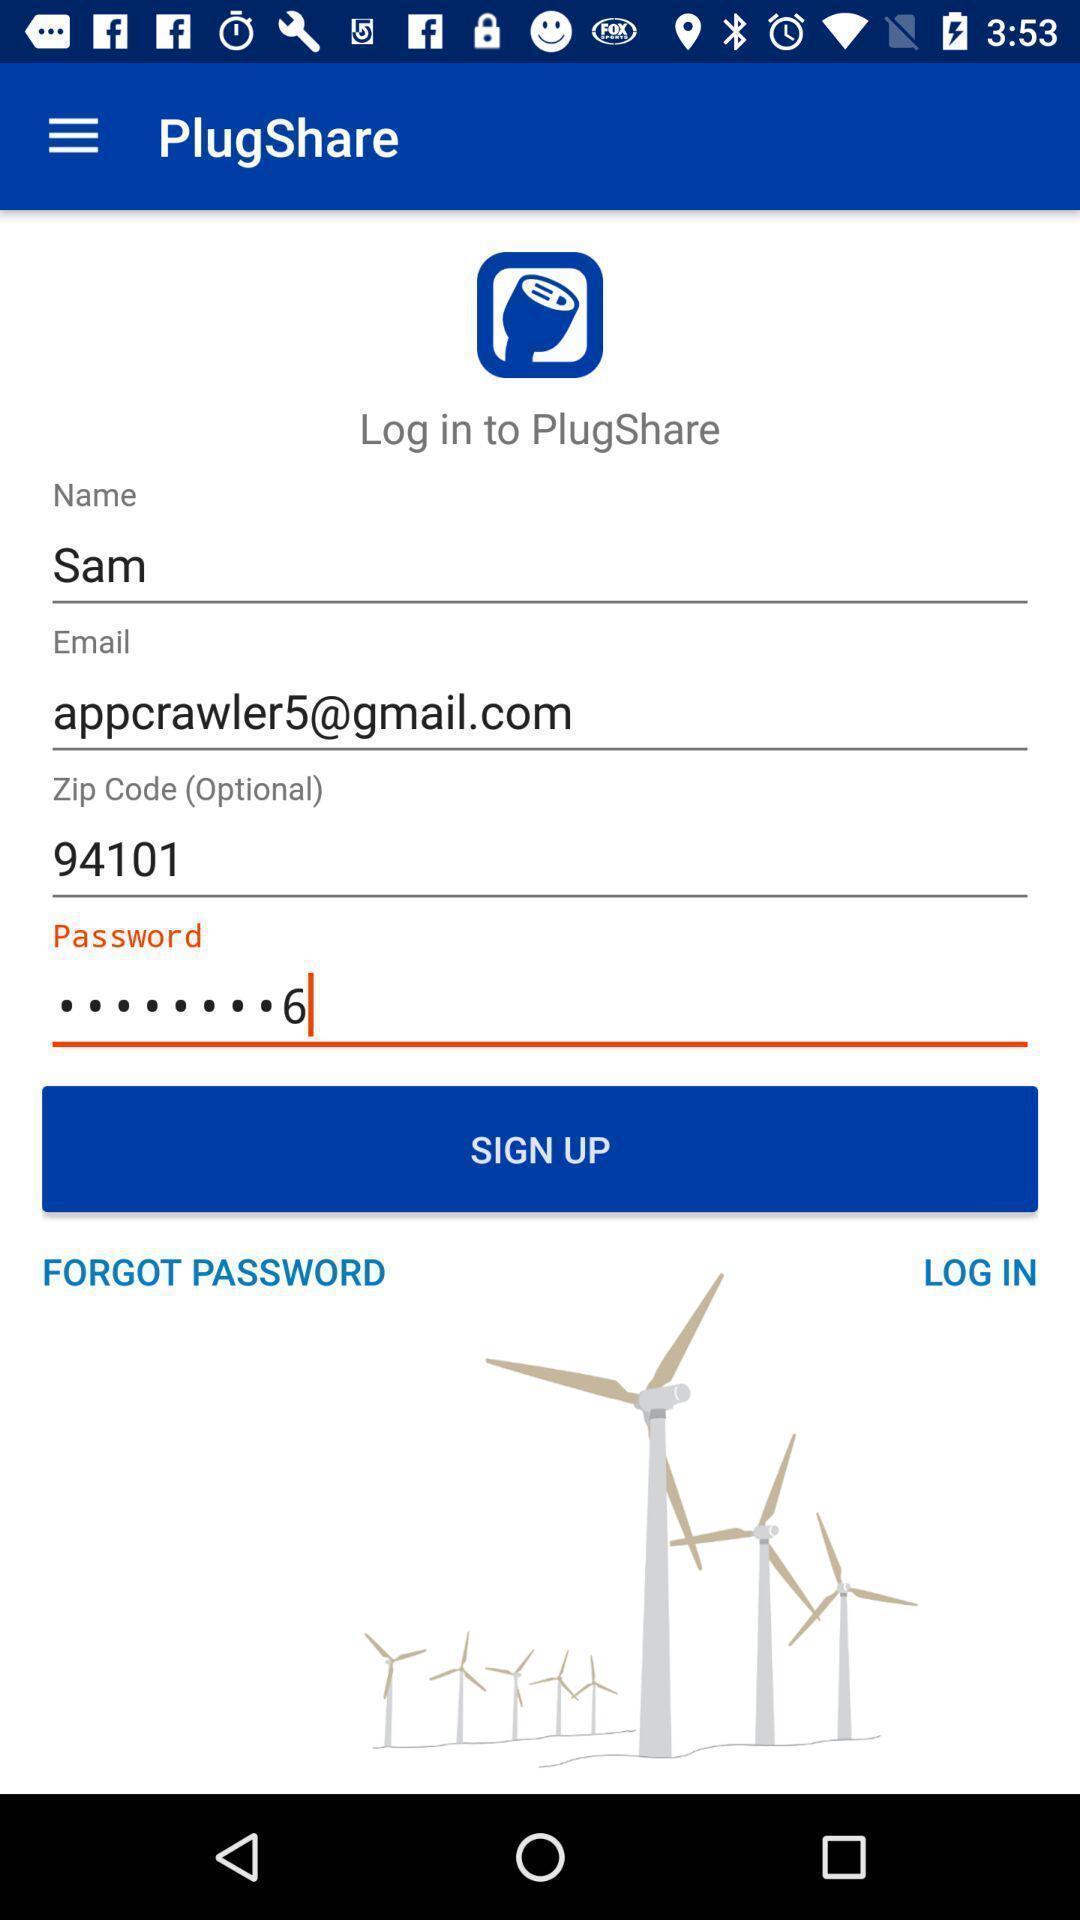Summarize the information in this screenshot. Sign up page of charging station application. 